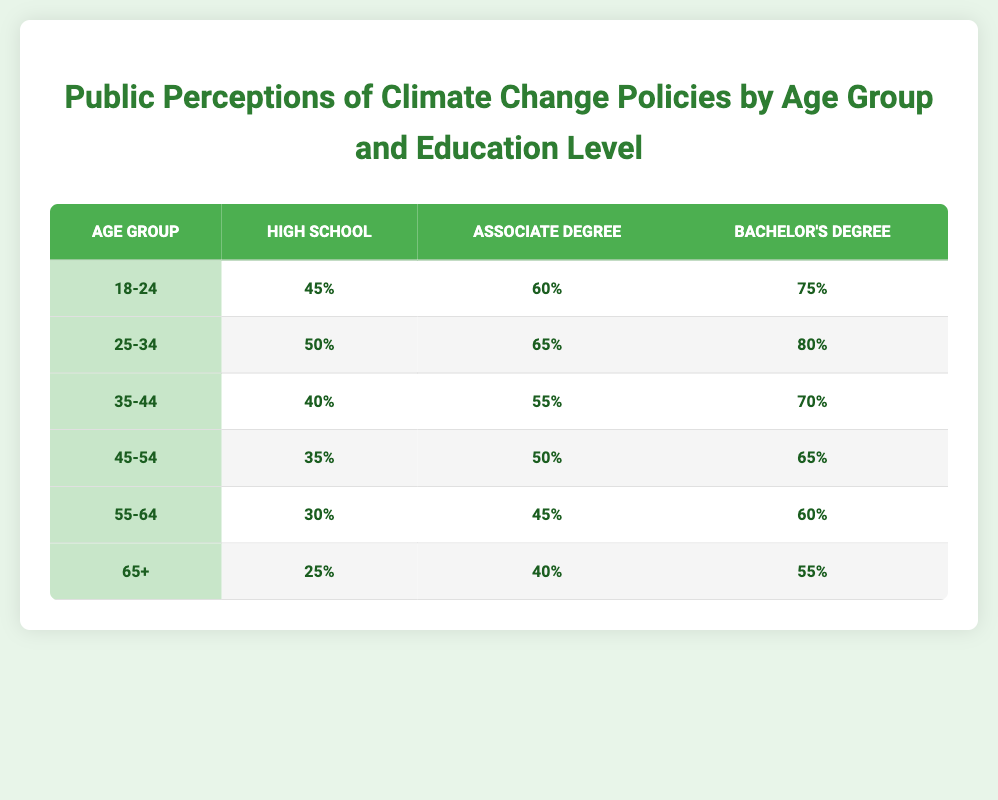What is the support level for individuals aged 18-24 with a Bachelor's Degree? The table shows the support level for 18-24 age group under Educated Degree as 75%.
Answer: 75% Which age group has the highest support level for climate change policies among those with an Associate Degree? Looking through the table, the 25-34 age group has the highest support level of 65% with an Associate Degree.
Answer: 65% Is the support level for the 45-54 age group higher among individuals with a Bachelor's Degree compared to those with a High School education? The Bachelor's Degree individuals in the 45-54 age group have a support level of 65%, while those with High School have 35%. Therefore, yes, it is higher.
Answer: Yes What is the average support level for individuals aged 55-64 across all education levels? The support levels for the 55-64 age group are 30% (High School), 45% (Associate Degree), and 60% (Bachelor's Degree). Summing these gives 30 + 45 + 60 = 135 and dividing by 3 gives an average of 135/3 = 45%.
Answer: 45% Are individuals aged 65 and older with a High School education the least supportive of climate change policies? Yes, the support level for individuals aged 65+ with a High School education is 25%, which is lower than all other age and education combinations in the table.
Answer: Yes Which age group shows an increase in support for climate change policies as education level increases, and by how much for those with data? All age groups indicate an increase in support as education level increases. For example, the 25-34 age group increases from 50% (High School) to 65% (Associate Degree), then to 80% (Bachelor's Degree). The increase is 30% from High School to Bachelor's Degree.
Answer: 30% What is the support level for older individuals (65+) with an Associate Degree compared to younger individuals (18-24) with a High School education? The support level for 65+ with an Associate Degree is 40%, while for 18-24 with a High School education it is 45%. Thus, the younger group has higher support.
Answer: No Which education level has the lowest support across all age groups? The lowest support overall is from individuals with a High School education, particularly in the 65+ age group at 25%.
Answer: 25% 